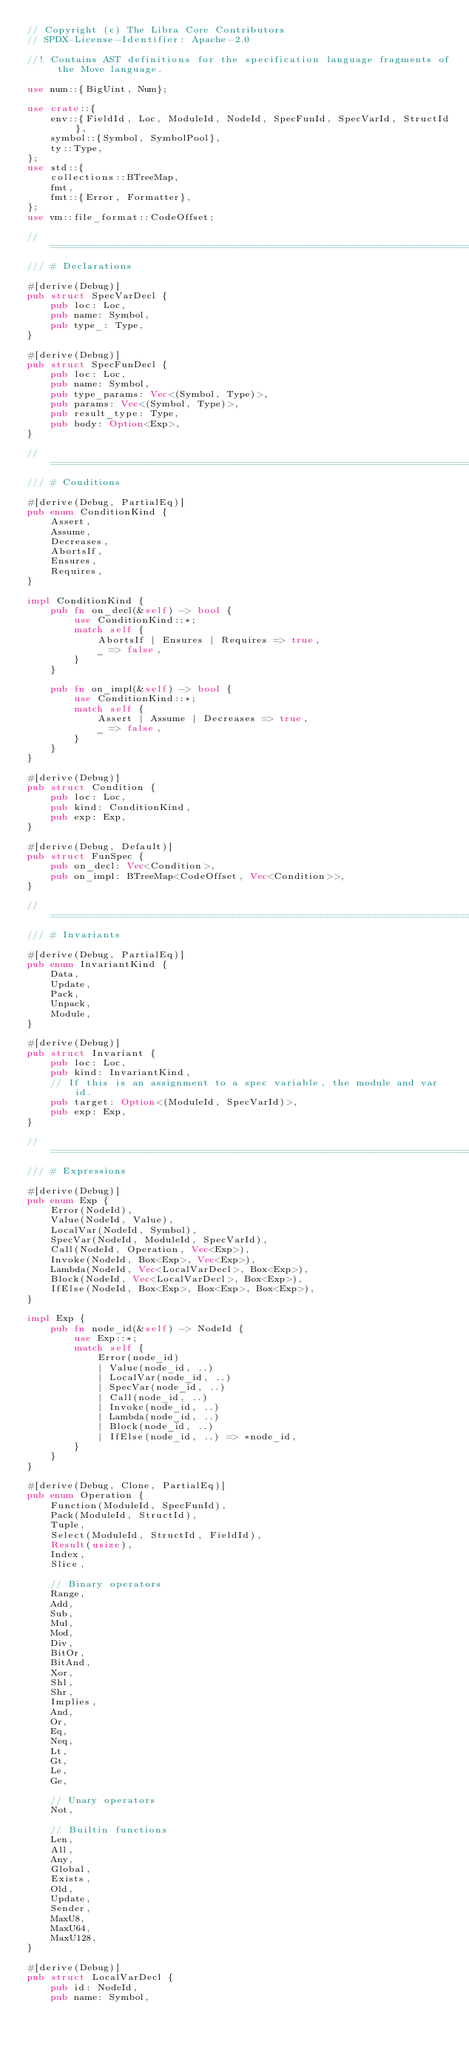<code> <loc_0><loc_0><loc_500><loc_500><_Rust_>// Copyright (c) The Libra Core Contributors
// SPDX-License-Identifier: Apache-2.0

//! Contains AST definitions for the specification language fragments of the Move language.

use num::{BigUint, Num};

use crate::{
    env::{FieldId, Loc, ModuleId, NodeId, SpecFunId, SpecVarId, StructId},
    symbol::{Symbol, SymbolPool},
    ty::Type,
};
use std::{
    collections::BTreeMap,
    fmt,
    fmt::{Error, Formatter},
};
use vm::file_format::CodeOffset;

// =================================================================================================
/// # Declarations

#[derive(Debug)]
pub struct SpecVarDecl {
    pub loc: Loc,
    pub name: Symbol,
    pub type_: Type,
}

#[derive(Debug)]
pub struct SpecFunDecl {
    pub loc: Loc,
    pub name: Symbol,
    pub type_params: Vec<(Symbol, Type)>,
    pub params: Vec<(Symbol, Type)>,
    pub result_type: Type,
    pub body: Option<Exp>,
}

// =================================================================================================
/// # Conditions

#[derive(Debug, PartialEq)]
pub enum ConditionKind {
    Assert,
    Assume,
    Decreases,
    AbortsIf,
    Ensures,
    Requires,
}

impl ConditionKind {
    pub fn on_decl(&self) -> bool {
        use ConditionKind::*;
        match self {
            AbortsIf | Ensures | Requires => true,
            _ => false,
        }
    }

    pub fn on_impl(&self) -> bool {
        use ConditionKind::*;
        match self {
            Assert | Assume | Decreases => true,
            _ => false,
        }
    }
}

#[derive(Debug)]
pub struct Condition {
    pub loc: Loc,
    pub kind: ConditionKind,
    pub exp: Exp,
}

#[derive(Debug, Default)]
pub struct FunSpec {
    pub on_decl: Vec<Condition>,
    pub on_impl: BTreeMap<CodeOffset, Vec<Condition>>,
}

// =================================================================================================
/// # Invariants

#[derive(Debug, PartialEq)]
pub enum InvariantKind {
    Data,
    Update,
    Pack,
    Unpack,
    Module,
}

#[derive(Debug)]
pub struct Invariant {
    pub loc: Loc,
    pub kind: InvariantKind,
    // If this is an assignment to a spec variable, the module and var id.
    pub target: Option<(ModuleId, SpecVarId)>,
    pub exp: Exp,
}

// =================================================================================================
/// # Expressions

#[derive(Debug)]
pub enum Exp {
    Error(NodeId),
    Value(NodeId, Value),
    LocalVar(NodeId, Symbol),
    SpecVar(NodeId, ModuleId, SpecVarId),
    Call(NodeId, Operation, Vec<Exp>),
    Invoke(NodeId, Box<Exp>, Vec<Exp>),
    Lambda(NodeId, Vec<LocalVarDecl>, Box<Exp>),
    Block(NodeId, Vec<LocalVarDecl>, Box<Exp>),
    IfElse(NodeId, Box<Exp>, Box<Exp>, Box<Exp>),
}

impl Exp {
    pub fn node_id(&self) -> NodeId {
        use Exp::*;
        match self {
            Error(node_id)
            | Value(node_id, ..)
            | LocalVar(node_id, ..)
            | SpecVar(node_id, ..)
            | Call(node_id, ..)
            | Invoke(node_id, ..)
            | Lambda(node_id, ..)
            | Block(node_id, ..)
            | IfElse(node_id, ..) => *node_id,
        }
    }
}

#[derive(Debug, Clone, PartialEq)]
pub enum Operation {
    Function(ModuleId, SpecFunId),
    Pack(ModuleId, StructId),
    Tuple,
    Select(ModuleId, StructId, FieldId),
    Result(usize),
    Index,
    Slice,

    // Binary operators
    Range,
    Add,
    Sub,
    Mul,
    Mod,
    Div,
    BitOr,
    BitAnd,
    Xor,
    Shl,
    Shr,
    Implies,
    And,
    Or,
    Eq,
    Neq,
    Lt,
    Gt,
    Le,
    Ge,

    // Unary operators
    Not,

    // Builtin functions
    Len,
    All,
    Any,
    Global,
    Exists,
    Old,
    Update,
    Sender,
    MaxU8,
    MaxU64,
    MaxU128,
}

#[derive(Debug)]
pub struct LocalVarDecl {
    pub id: NodeId,
    pub name: Symbol,</code> 